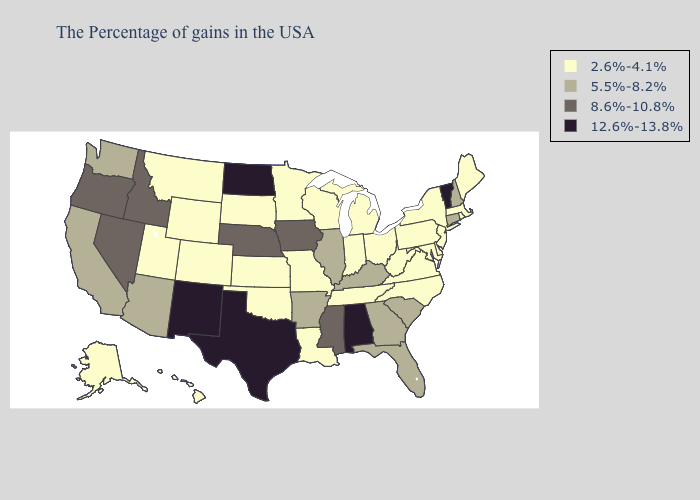Does Iowa have the lowest value in the MidWest?
Write a very short answer. No. What is the value of Nebraska?
Concise answer only. 8.6%-10.8%. Among the states that border Nevada , does California have the lowest value?
Short answer required. No. Name the states that have a value in the range 12.6%-13.8%?
Keep it brief. Vermont, Alabama, Texas, North Dakota, New Mexico. What is the highest value in the Northeast ?
Quick response, please. 12.6%-13.8%. What is the value of South Dakota?
Short answer required. 2.6%-4.1%. What is the value of Louisiana?
Concise answer only. 2.6%-4.1%. Among the states that border South Dakota , does North Dakota have the highest value?
Concise answer only. Yes. What is the value of Kentucky?
Quick response, please. 5.5%-8.2%. Which states have the lowest value in the USA?
Short answer required. Maine, Massachusetts, Rhode Island, New York, New Jersey, Delaware, Maryland, Pennsylvania, Virginia, North Carolina, West Virginia, Ohio, Michigan, Indiana, Tennessee, Wisconsin, Louisiana, Missouri, Minnesota, Kansas, Oklahoma, South Dakota, Wyoming, Colorado, Utah, Montana, Alaska, Hawaii. Does the map have missing data?
Answer briefly. No. Name the states that have a value in the range 8.6%-10.8%?
Give a very brief answer. Mississippi, Iowa, Nebraska, Idaho, Nevada, Oregon. What is the highest value in the Northeast ?
Give a very brief answer. 12.6%-13.8%. Does Indiana have the lowest value in the USA?
Write a very short answer. Yes. 